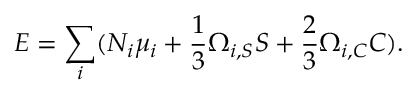<formula> <loc_0><loc_0><loc_500><loc_500>E = \sum _ { i } ( N _ { i } \mu _ { i } + { \frac { 1 } { 3 } } \Omega _ { i , S } S + { \frac { 2 } { 3 } } \Omega _ { i , C } C ) .</formula> 